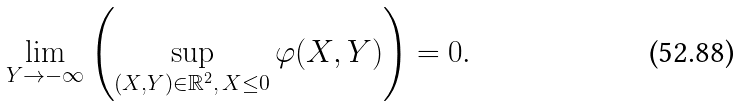Convert formula to latex. <formula><loc_0><loc_0><loc_500><loc_500>\lim _ { Y \rightarrow - \infty } \left ( \sup _ { ( X , Y ) \in \mathbb { R } ^ { 2 } , \, { X \leq 0 } } \varphi ( X , Y ) \right ) = 0 .</formula> 